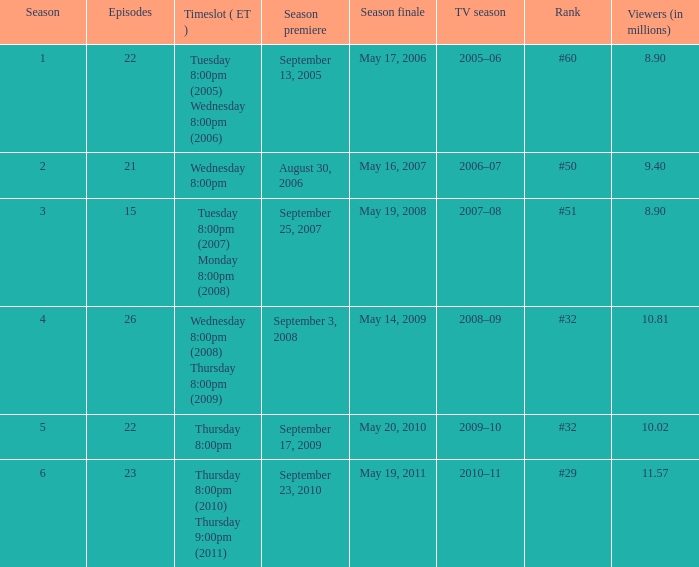When did the season finale achieve a viewership of 10.02 million people? May 20, 2010. 